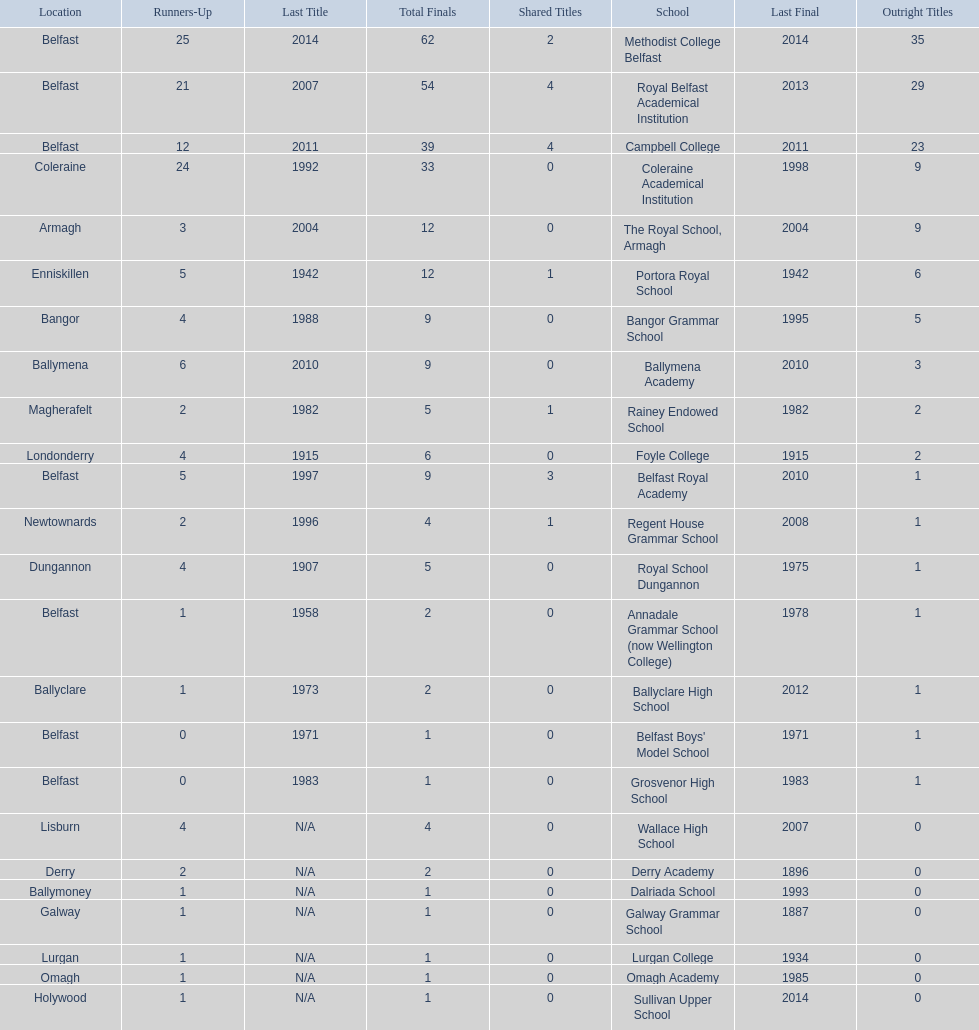What number of total finals does foyle college have? 6. 